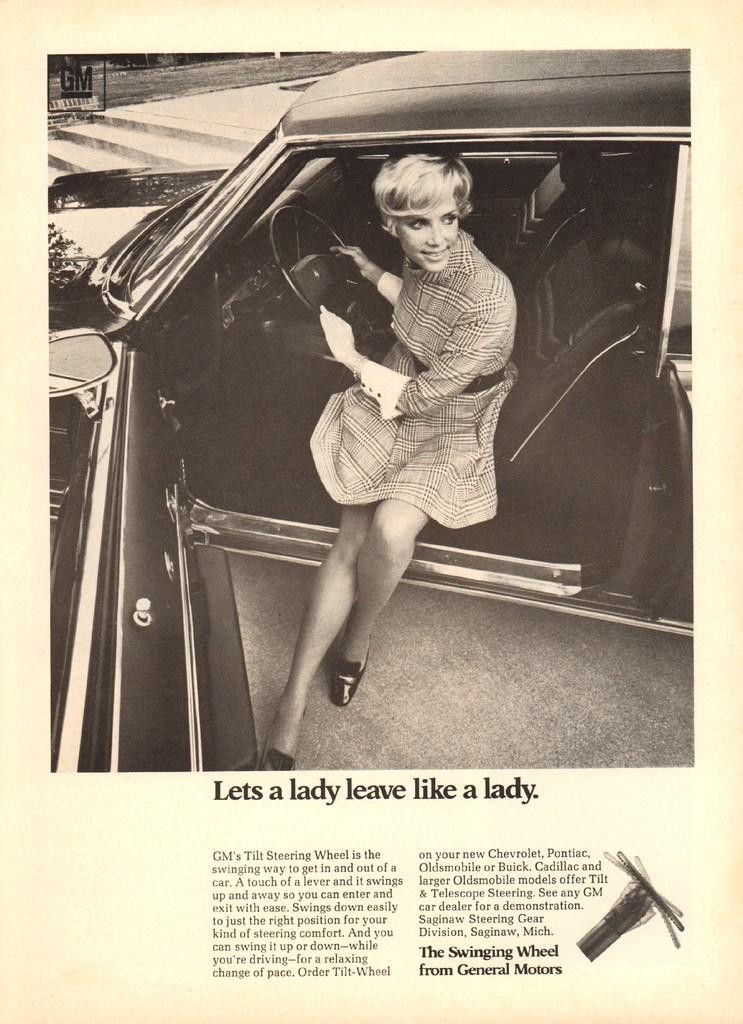Describe this image in one or two sentences. This image is a photo copy of a newspaper as we can see there is one women sitting in the car at top of this image and there is a car in middle of this image and there is some text written at bottom of this image and there is one watermark at top left corner of this image. 